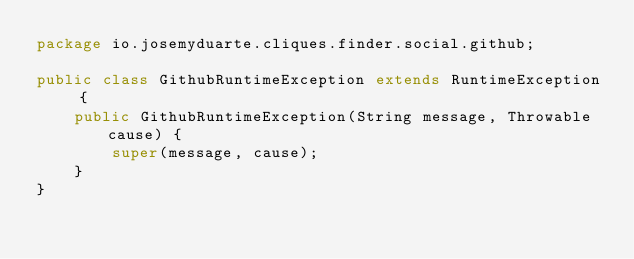Convert code to text. <code><loc_0><loc_0><loc_500><loc_500><_Java_>package io.josemyduarte.cliques.finder.social.github;

public class GithubRuntimeException extends RuntimeException {
    public GithubRuntimeException(String message, Throwable cause) {
        super(message, cause);
    }
}
</code> 